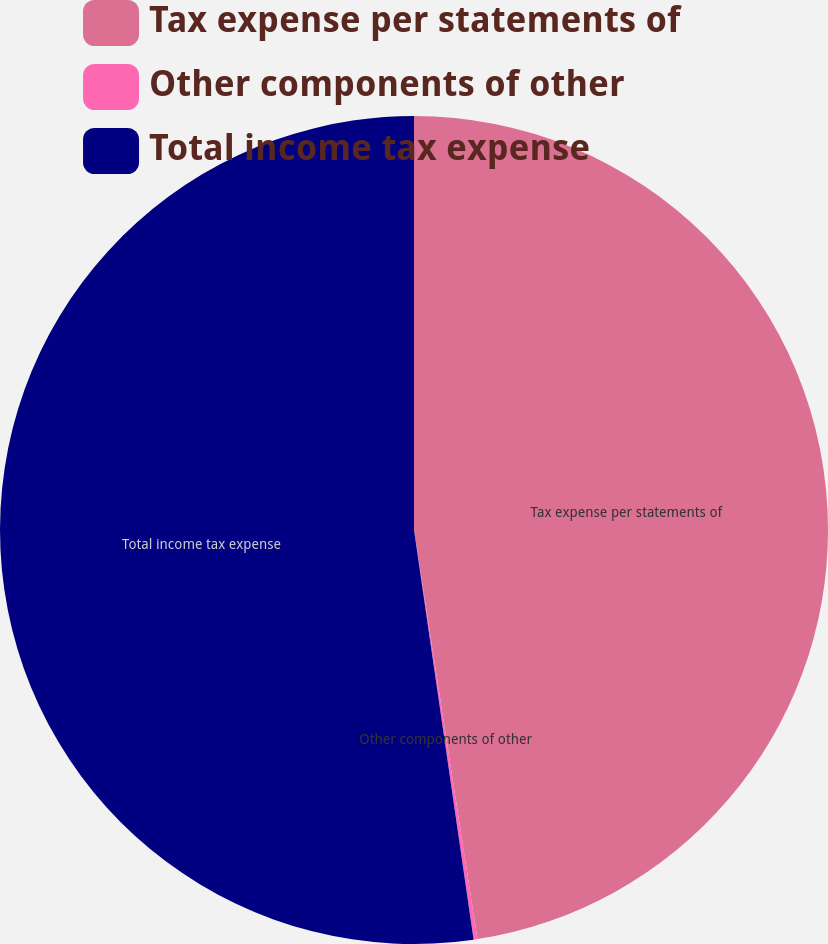Convert chart to OTSL. <chart><loc_0><loc_0><loc_500><loc_500><pie_chart><fcel>Tax expense per statements of<fcel>Other components of other<fcel>Total income tax expense<nl><fcel>47.55%<fcel>0.15%<fcel>52.3%<nl></chart> 